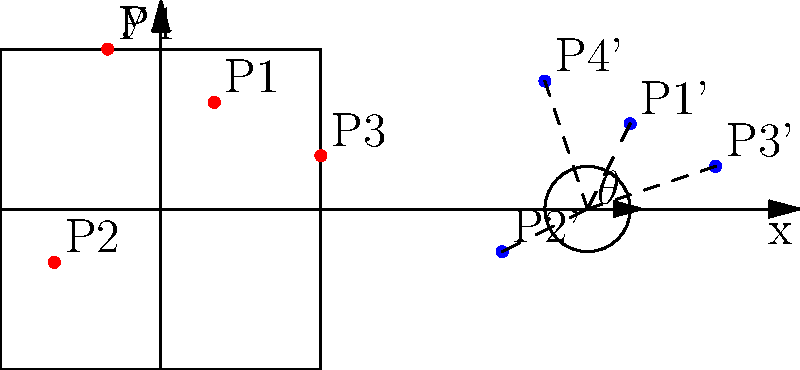Given the four points P1(1,2), P2(-2,-1), P3(3,1), and P4(-1,3) in Cartesian coordinates, transform these points to polar coordinates and visualize the result. Which point has the largest polar angle $\theta$ in the range $[0, 2\pi)$? To solve this problem, we need to follow these steps:

1. Transform each point from Cartesian (x,y) to polar (r,θ) coordinates:
   $r = \sqrt{x^2 + y^2}$
   $\theta = \tan^{-1}(\frac{y}{x})$, adjusted for the correct quadrant

2. Calculate r and θ for each point:

   P1(1,2):
   $r_1 = \sqrt{1^2 + 2^2} = \sqrt{5}$
   $\theta_1 = \tan^{-1}(\frac{2}{1}) \approx 1.107$ rad (63.4°)

   P2(-2,-1):
   $r_2 = \sqrt{(-2)^2 + (-1)^2} = \sqrt{5}$
   $\theta_2 = \tan^{-1}(\frac{-1}{-2}) + \pi \approx 3.927$ rad (225.0°)

   P3(3,1):
   $r_3 = \sqrt{3^2 + 1^2} = \sqrt{10}$
   $\theta_3 = \tan^{-1}(\frac{1}{3}) \approx 0.322$ rad (18.4°)

   P4(-1,3):
   $r_4 = \sqrt{(-1)^2 + 3^2} = \sqrt{10}$
   $\theta_4 = \tan^{-1}(\frac{3}{-1}) + \pi \approx 2.820$ rad (161.6°)

3. Compare the θ values:
   θ1 ≈ 1.107 rad
   θ2 ≈ 3.927 rad
   θ3 ≈ 0.322 rad
   θ4 ≈ 2.820 rad

The largest θ value is θ2, corresponding to point P2.
Answer: P2(-2,-1) with $\theta \approx 3.927$ rad (225.0°) 